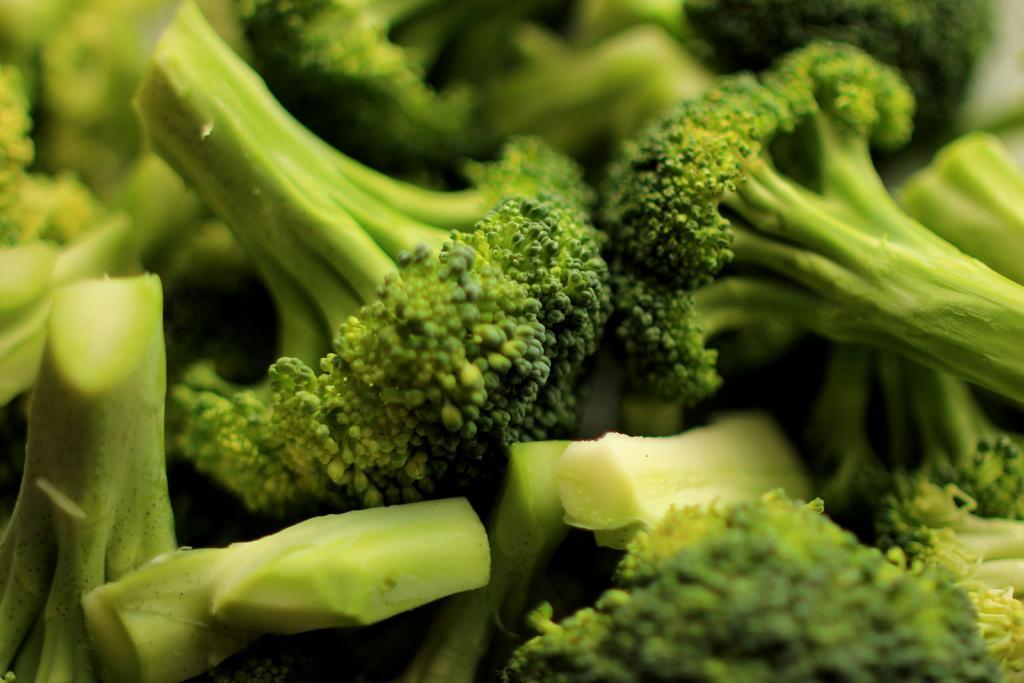In one or two sentences, can you explain what this image depicts? There are pieces of broccoli in the image. 